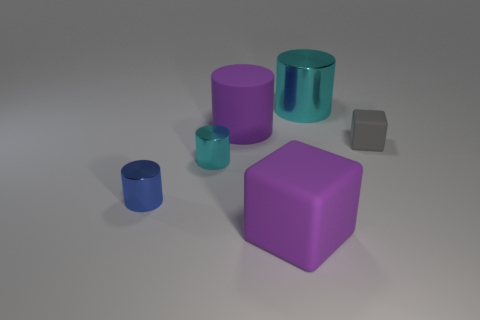The rubber cube that is the same color as the big matte cylinder is what size?
Your answer should be very brief. Large. Are there an equal number of metal objects behind the large metal thing and tiny metal objects that are in front of the large matte cube?
Your answer should be compact. Yes. There is a tiny cyan metallic object; are there any gray matte blocks left of it?
Provide a short and direct response. No. What color is the matte object in front of the tiny blue metallic object?
Your answer should be very brief. Purple. There is a cyan thing that is in front of the matte block behind the purple matte block; what is it made of?
Make the answer very short. Metal. Are there fewer purple blocks to the right of the small gray matte cube than big cylinders that are in front of the big cyan cylinder?
Provide a short and direct response. Yes. What number of gray objects are either big things or big cylinders?
Provide a short and direct response. 0. Are there an equal number of big cylinders that are right of the rubber cylinder and objects?
Give a very brief answer. No. What number of things are either tiny yellow cubes or large cyan metal objects on the right side of the blue cylinder?
Give a very brief answer. 1. Is the big metal cylinder the same color as the matte cylinder?
Give a very brief answer. No. 